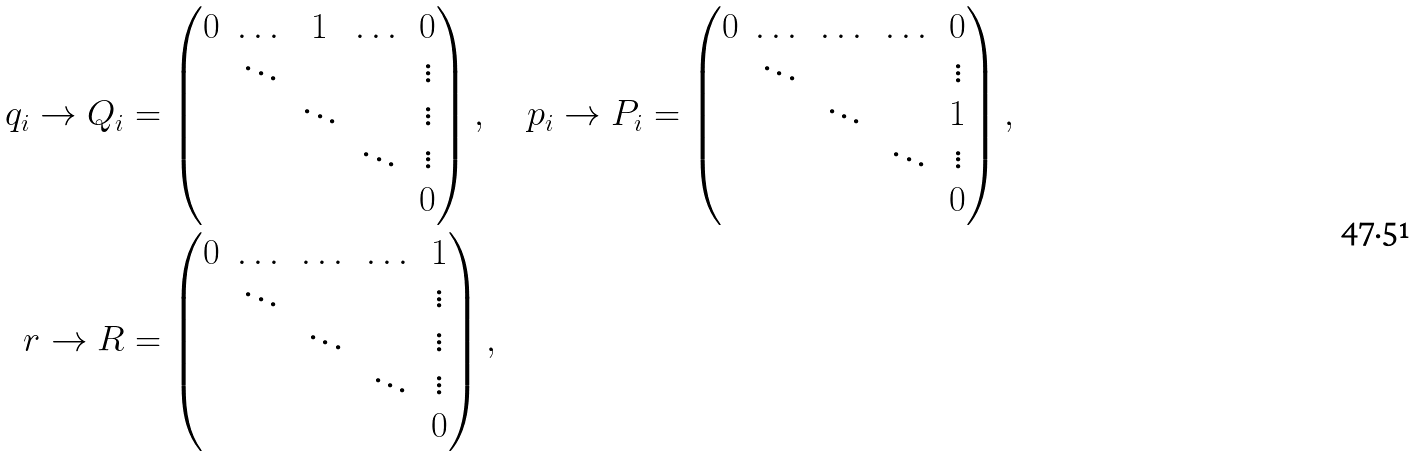<formula> <loc_0><loc_0><loc_500><loc_500>q _ { i } \to Q _ { i } & = \begin{pmatrix} 0 & \dots & 1 & \dots & 0 \\ & \ddots & & & \vdots \\ & & \ddots & & \vdots \\ & & & \ddots & \vdots \\ & & & & 0 \\ \end{pmatrix} , \quad p _ { i } \to P _ { i } = \begin{pmatrix} 0 & \dots & \dots & \dots & 0 \\ & \ddots & & & \vdots \\ & & \ddots & & 1 \\ & & & \ddots & \vdots \\ & & & & 0 \\ \end{pmatrix} , \\ r \to R & = \begin{pmatrix} 0 & \dots & \dots & \dots & 1 \\ & \ddots & & & \vdots \\ & & \ddots & & \vdots \\ & & & \ddots & \vdots \\ & & & & 0 \\ \end{pmatrix} ,</formula> 